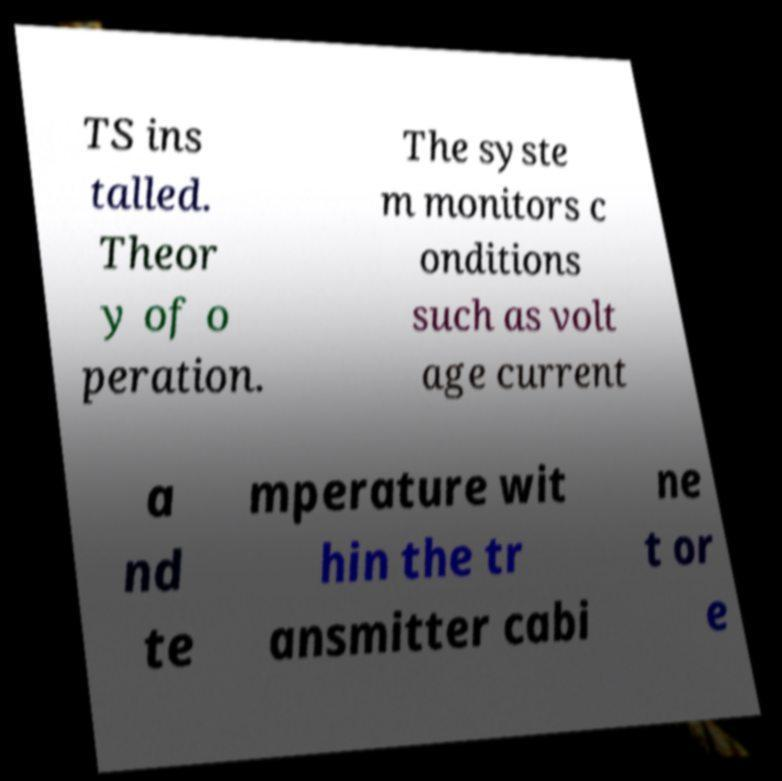Can you read and provide the text displayed in the image?This photo seems to have some interesting text. Can you extract and type it out for me? TS ins talled. Theor y of o peration. The syste m monitors c onditions such as volt age current a nd te mperature wit hin the tr ansmitter cabi ne t or e 